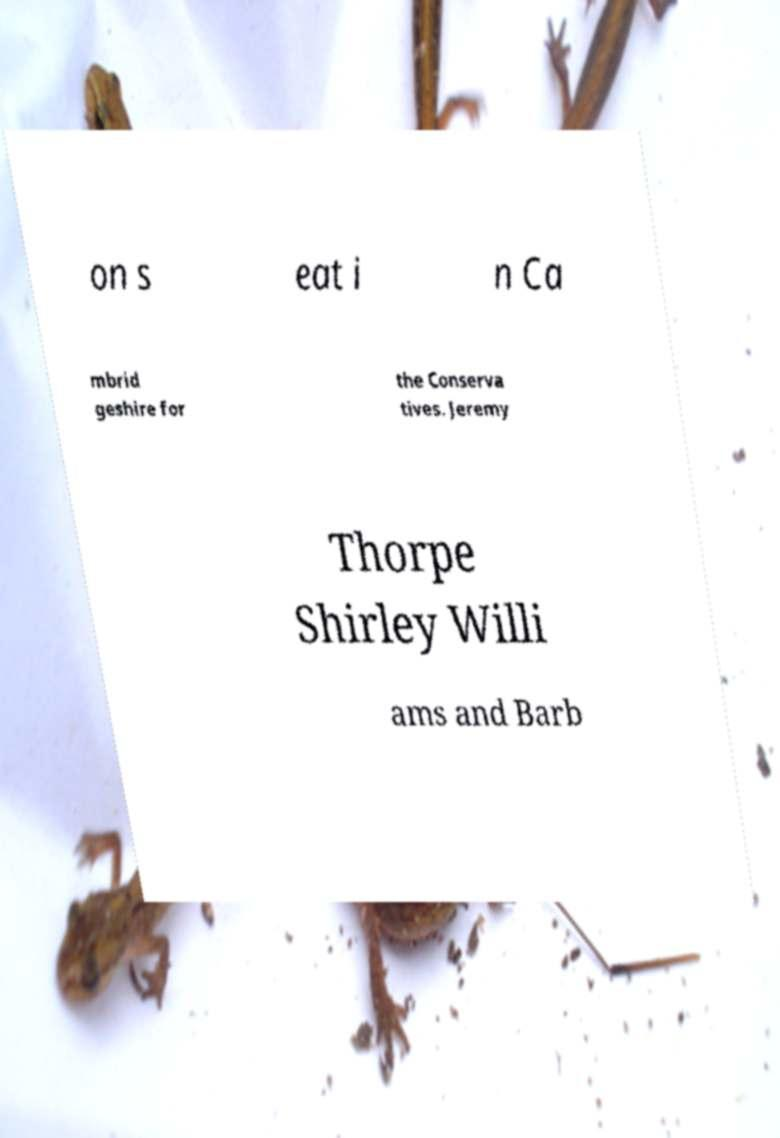Please identify and transcribe the text found in this image. on s eat i n Ca mbrid geshire for the Conserva tives. Jeremy Thorpe Shirley Willi ams and Barb 